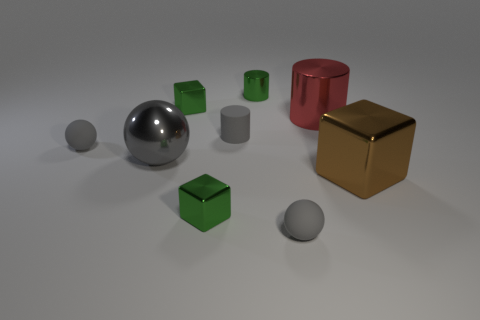There is a cylinder that is the same color as the big shiny sphere; what is it made of?
Give a very brief answer. Rubber. Are the gray thing right of the green shiny cylinder and the cube in front of the brown thing made of the same material?
Offer a terse response. No. There is a gray metallic thing that is the same size as the red metal object; what shape is it?
Offer a very short reply. Sphere. What number of other things are there of the same color as the large block?
Your answer should be very brief. 0. There is a large object that is right of the red object; what is its color?
Your response must be concise. Brown. What number of other objects are there of the same material as the large red thing?
Ensure brevity in your answer.  5. Are there more big cubes behind the big metal cylinder than small metallic objects behind the big ball?
Offer a very short reply. No. There is a brown metal block; what number of small matte objects are on the right side of it?
Ensure brevity in your answer.  0. Is the red cylinder made of the same material as the big object that is on the left side of the tiny green metallic cylinder?
Make the answer very short. Yes. Is there any other thing that is the same shape as the large red object?
Your answer should be compact. Yes. 